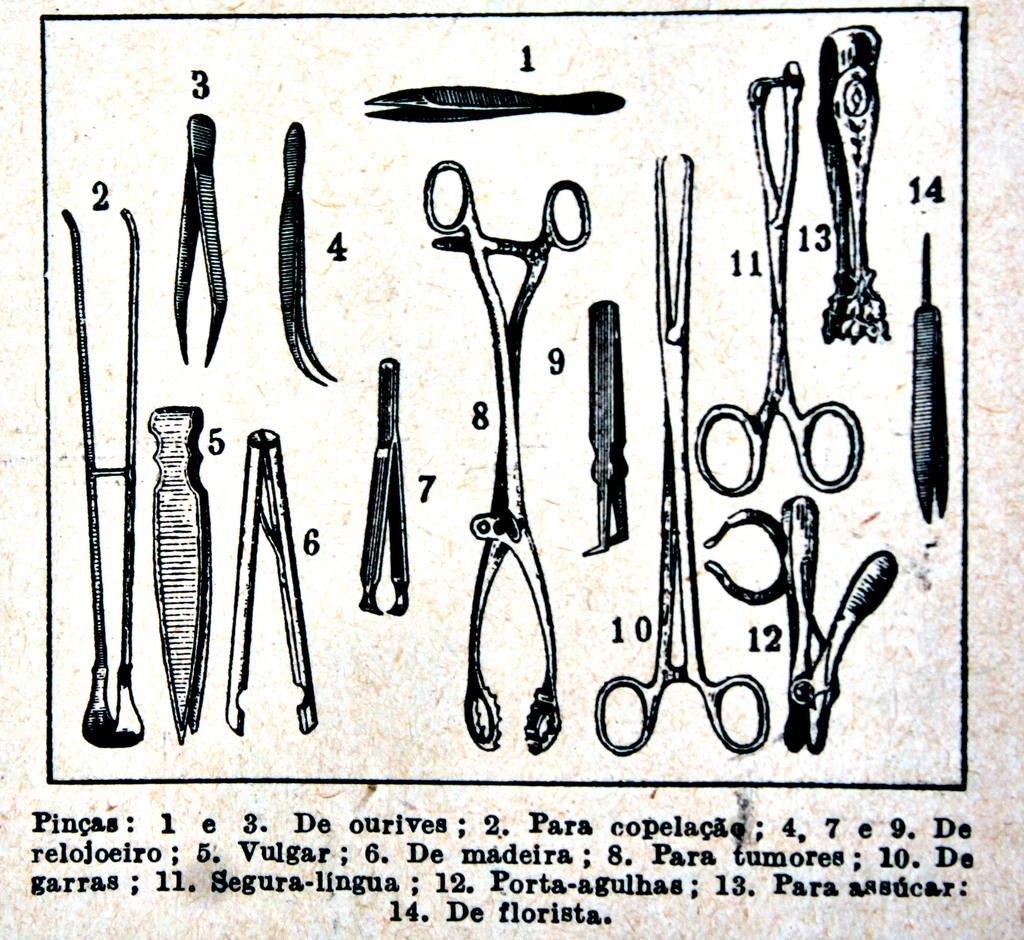What is the medium of the image? The image is on a paper. What is depicted in the image on the paper? There is a picture of tools on the paper. What else can be found on the paper besides the image? There are letters and numbers on the paper. What is the name of the nation depicted in the image? There is no nation depicted in the image; it features a picture of tools. How many feet are visible in the image? There are no feet present in the image. 